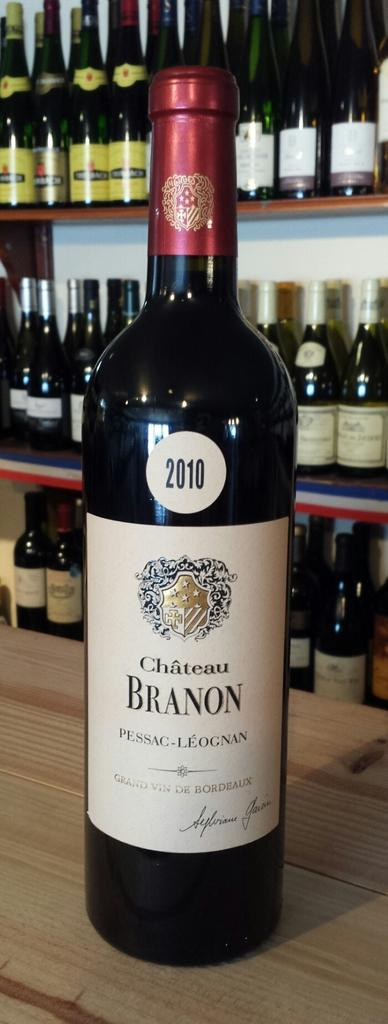<image>
Render a clear and concise summary of the photo. A bottle of wine with the date 2010 and the word Branon on the label. 